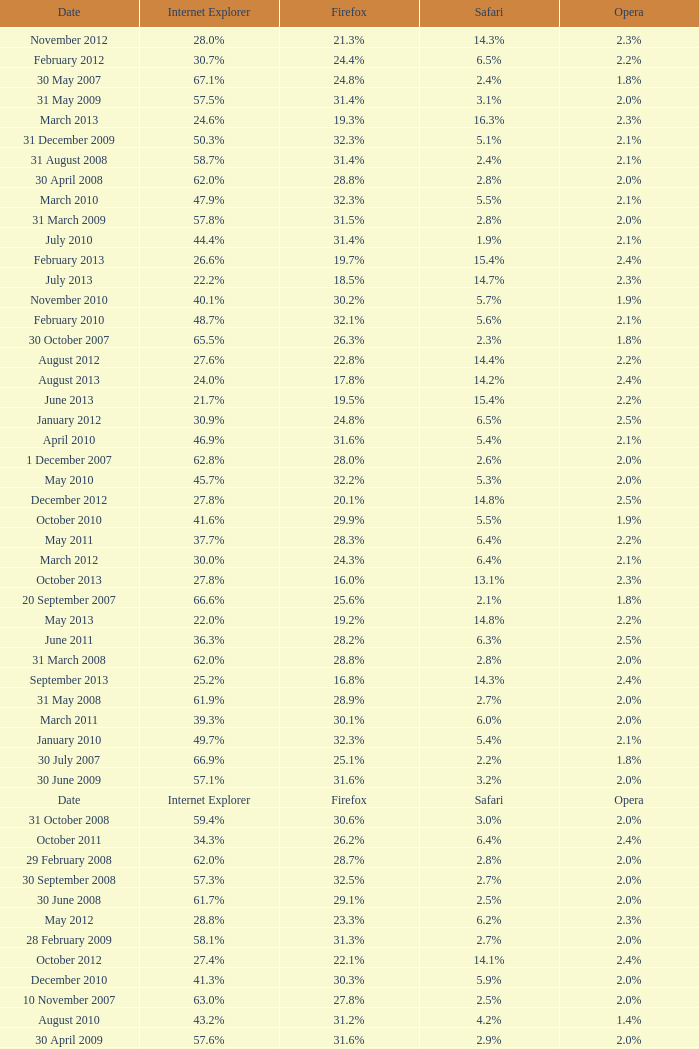What is the safari value with a 2.4% opera and 29.9% internet explorer? 6.5%. 